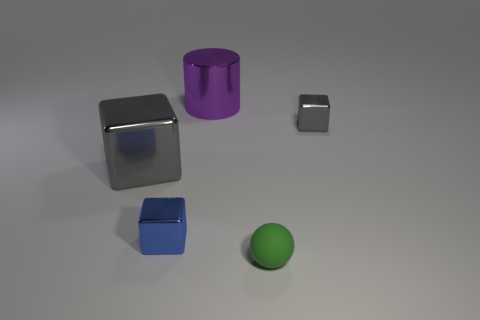Add 2 purple things. How many objects exist? 7 Subtract all spheres. How many objects are left? 4 Subtract 0 gray cylinders. How many objects are left? 5 Subtract all gray matte cylinders. Subtract all gray metallic cubes. How many objects are left? 3 Add 3 gray metal cubes. How many gray metal cubes are left? 5 Add 3 metallic cylinders. How many metallic cylinders exist? 4 